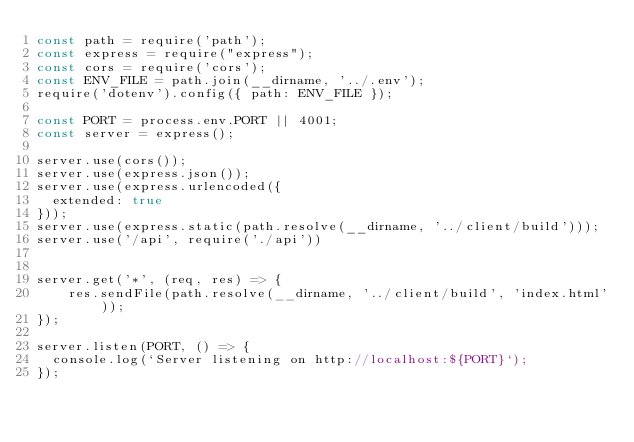<code> <loc_0><loc_0><loc_500><loc_500><_JavaScript_>const path = require('path');
const express = require("express");
const cors = require('cors');
const ENV_FILE = path.join(__dirname, '../.env');
require('dotenv').config({ path: ENV_FILE });

const PORT = process.env.PORT || 4001;
const server = express();

server.use(cors());
server.use(express.json());
server.use(express.urlencoded({
  extended: true
}));
server.use(express.static(path.resolve(__dirname, '../client/build')));
server.use('/api', require('./api'))


server.get('*', (req, res) => {
    res.sendFile(path.resolve(__dirname, '../client/build', 'index.html'));
});

server.listen(PORT, () => {
  console.log(`Server listening on http://localhost:${PORT}`);
});</code> 